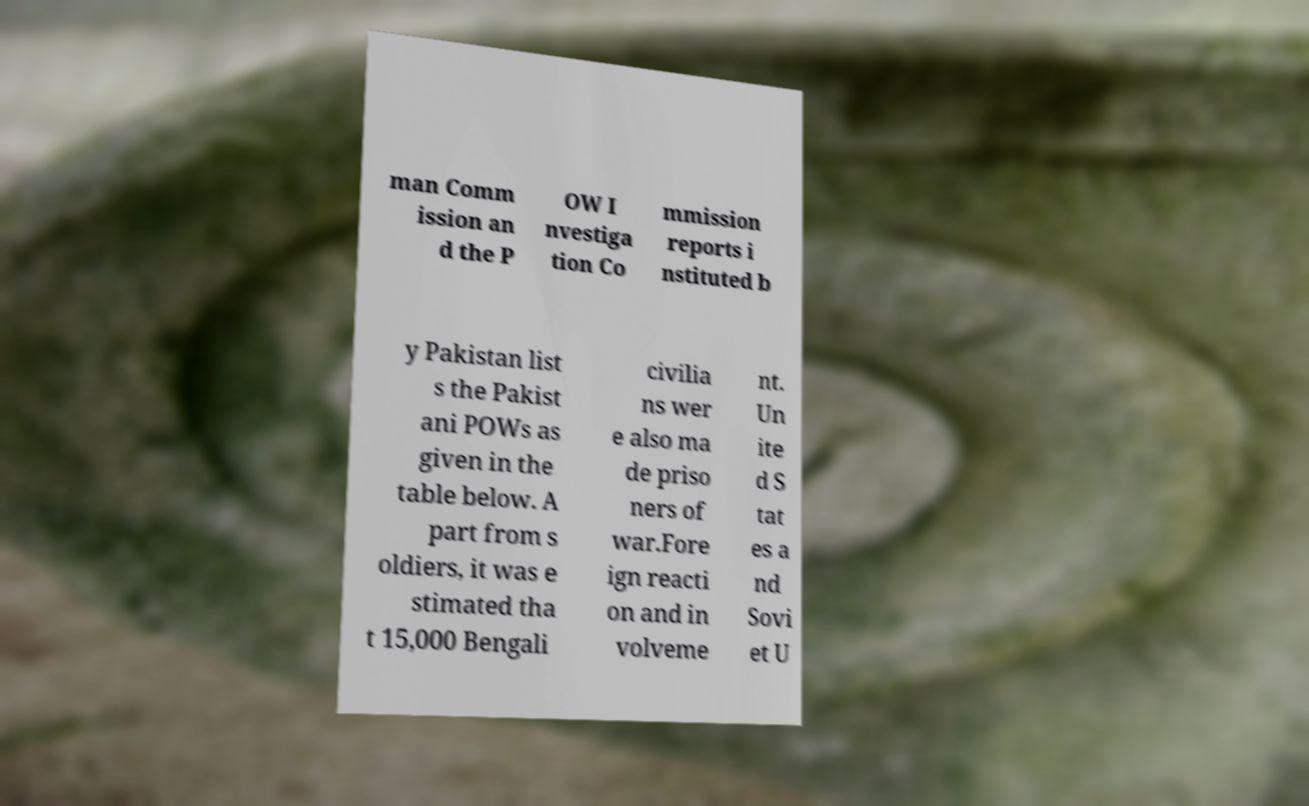Can you read and provide the text displayed in the image?This photo seems to have some interesting text. Can you extract and type it out for me? man Comm ission an d the P OW I nvestiga tion Co mmission reports i nstituted b y Pakistan list s the Pakist ani POWs as given in the table below. A part from s oldiers, it was e stimated tha t 15,000 Bengali civilia ns wer e also ma de priso ners of war.Fore ign reacti on and in volveme nt. Un ite d S tat es a nd Sovi et U 